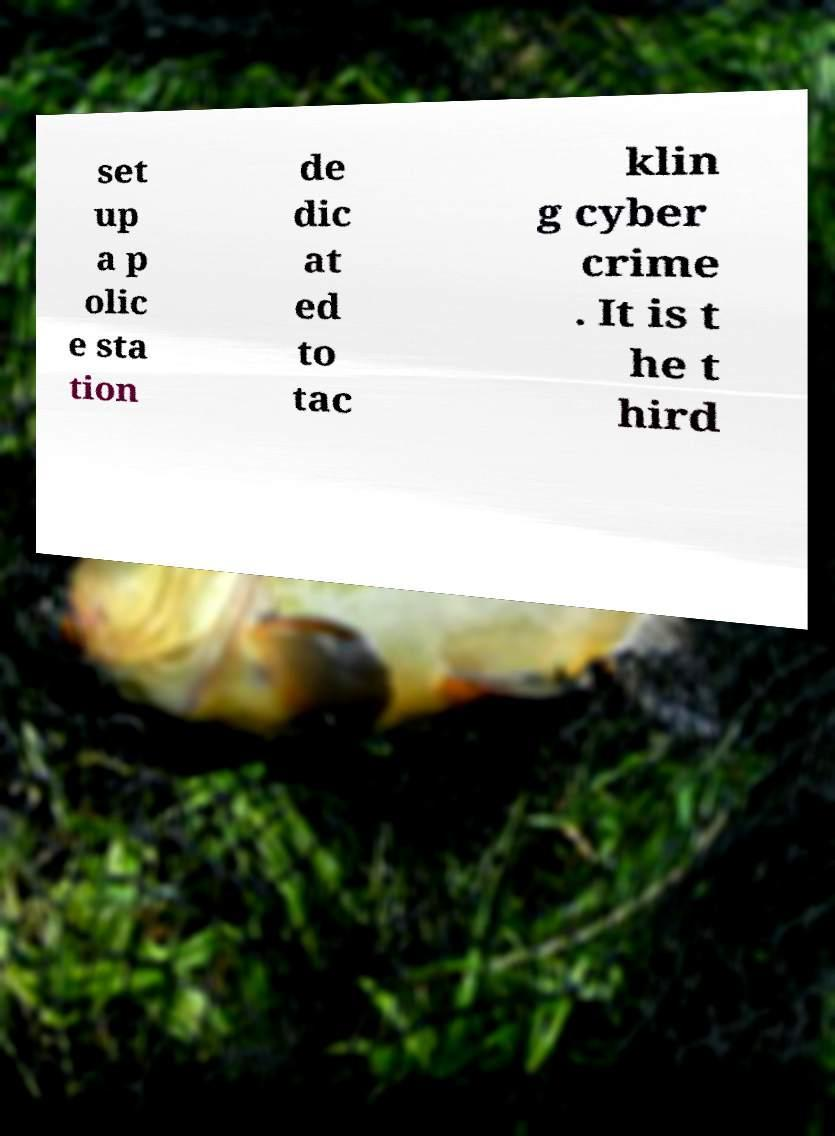Can you accurately transcribe the text from the provided image for me? set up a p olic e sta tion de dic at ed to tac klin g cyber crime . It is t he t hird 